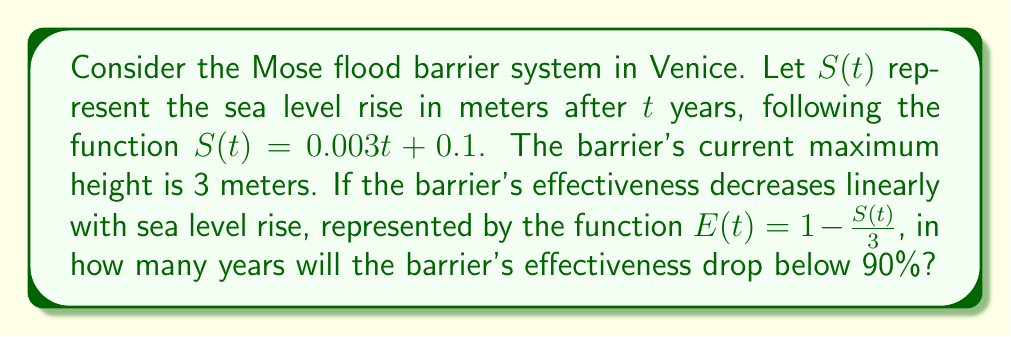Show me your answer to this math problem. To solve this problem, we need to follow these steps:

1) First, we need to set up the equation for when the effectiveness drops below 90%:

   $E(t) < 0.9$

2) We can substitute the given function for $E(t)$:

   $1 - \frac{S(t)}{3} < 0.9$

3) Now, we can substitute the function for $S(t)$:

   $1 - \frac{0.003t + 0.1}{3} < 0.9$

4) Let's solve this inequality:

   $1 - \frac{0.003t + 0.1}{3} < 0.9$
   $-\frac{0.003t + 0.1}{3} < -0.1$
   $0.003t + 0.1 > 0.3$
   $0.003t > 0.2$
   $t > \frac{0.2}{0.003}$
   $t > 66.67$

5) Since we're dealing with years, we need to round up to the next whole number.

Therefore, the barrier's effectiveness will drop below 90% after 67 years.
Answer: 67 years 